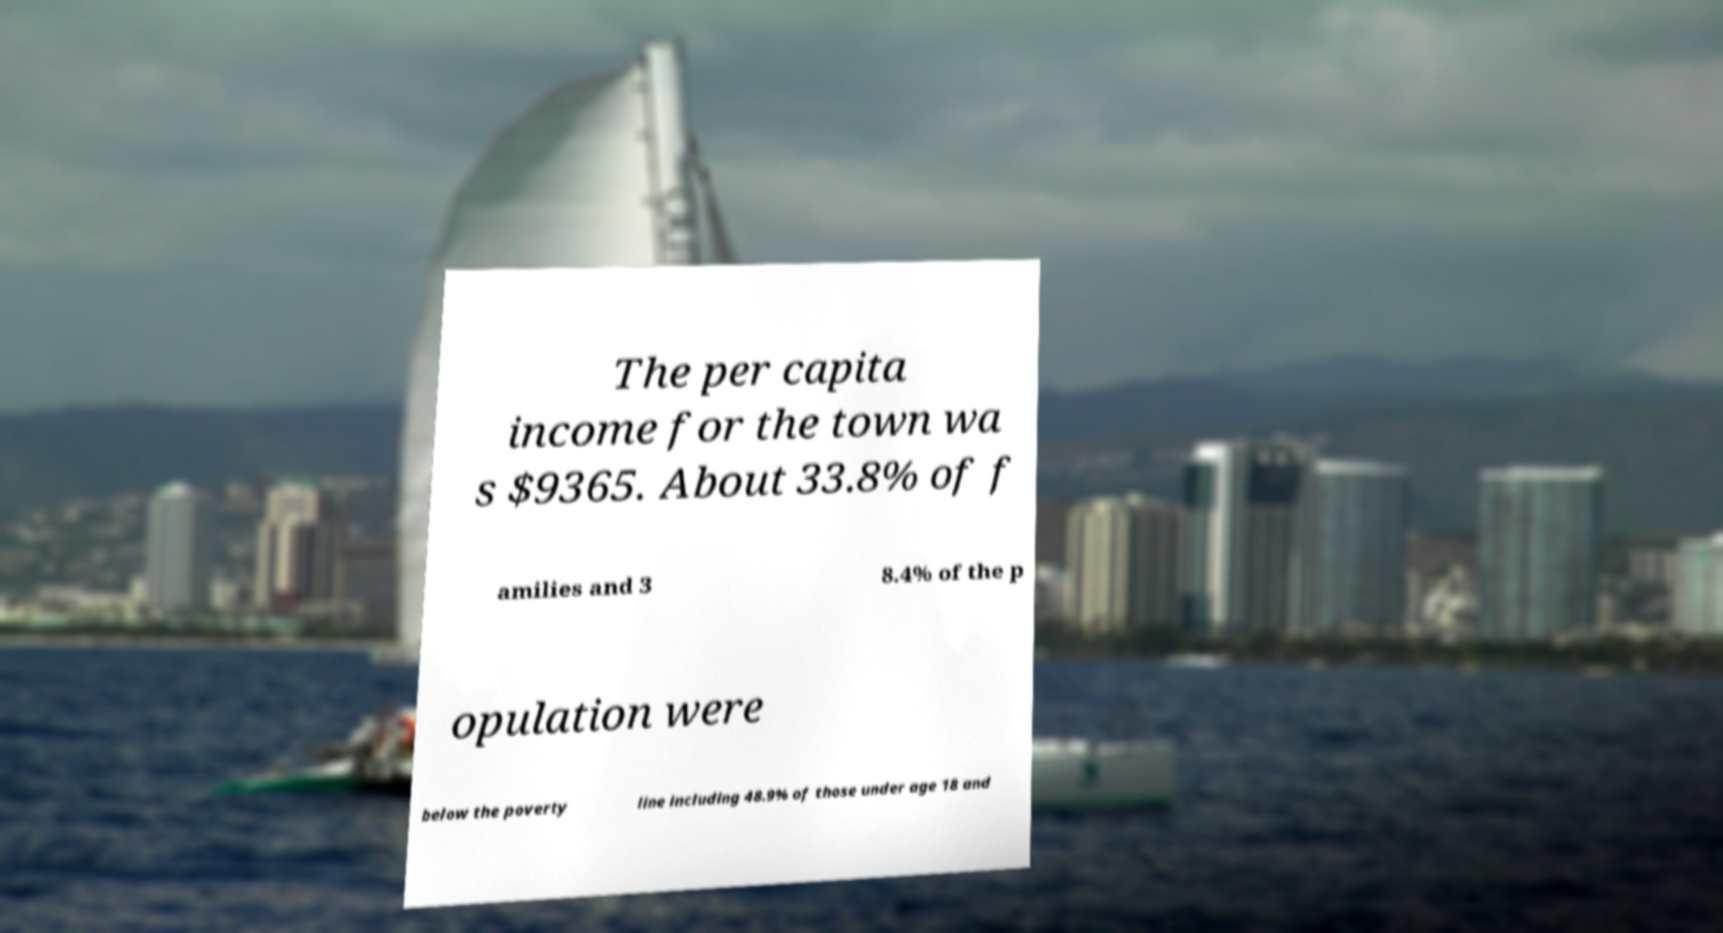What messages or text are displayed in this image? I need them in a readable, typed format. The per capita income for the town wa s $9365. About 33.8% of f amilies and 3 8.4% of the p opulation were below the poverty line including 48.9% of those under age 18 and 